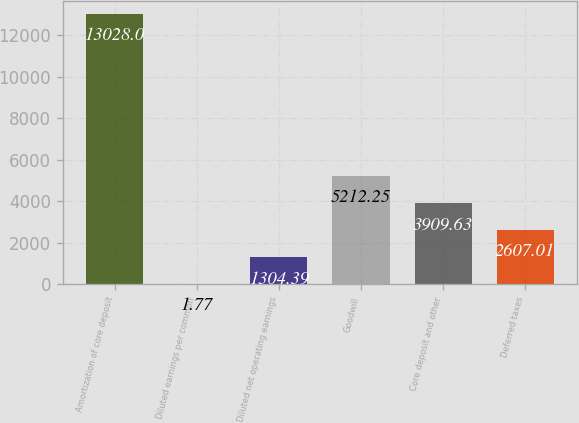<chart> <loc_0><loc_0><loc_500><loc_500><bar_chart><fcel>Amortization of core deposit<fcel>Diluted earnings per common<fcel>Diluted net operating earnings<fcel>Goodwill<fcel>Core deposit and other<fcel>Deferred taxes<nl><fcel>13028<fcel>1.77<fcel>1304.39<fcel>5212.25<fcel>3909.63<fcel>2607.01<nl></chart> 